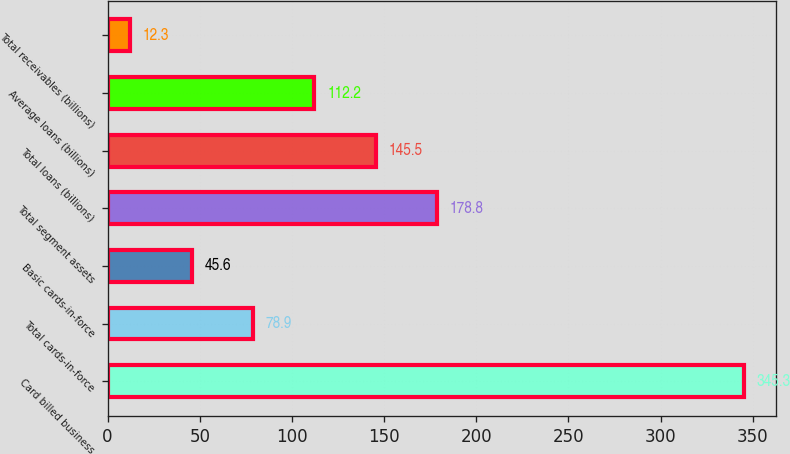Convert chart. <chart><loc_0><loc_0><loc_500><loc_500><bar_chart><fcel>Card billed business<fcel>Total cards-in-force<fcel>Basic cards-in-force<fcel>Total segment assets<fcel>Total loans (billions)<fcel>Average loans (billions)<fcel>Total receivables (billions)<nl><fcel>345.3<fcel>78.9<fcel>45.6<fcel>178.8<fcel>145.5<fcel>112.2<fcel>12.3<nl></chart> 